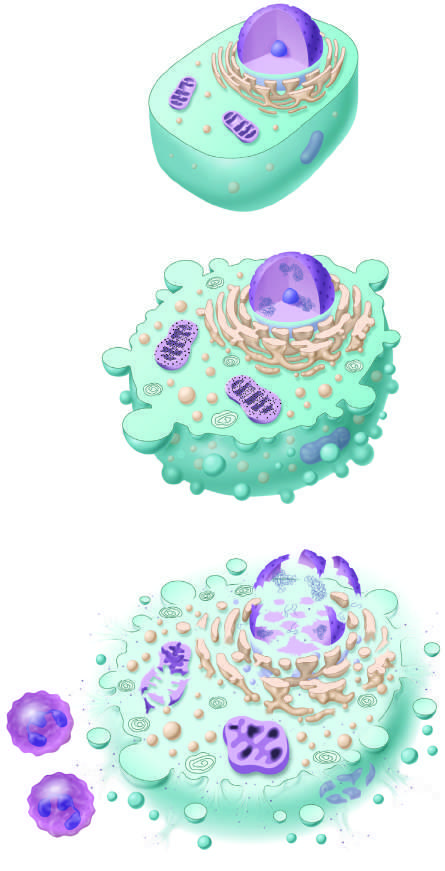re methylation of particular histone residues illustrated?
Answer the question using a single word or phrase. No 